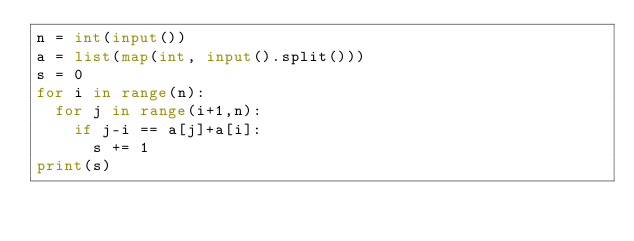<code> <loc_0><loc_0><loc_500><loc_500><_Python_>n = int(input())
a = list(map(int, input().split()))
s = 0
for i in range(n):
  for j in range(i+1,n):
    if j-i == a[j]+a[i]:
      s += 1
print(s)</code> 